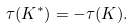<formula> <loc_0><loc_0><loc_500><loc_500>\tau ( K ^ { * } ) = - \tau ( K ) .</formula> 